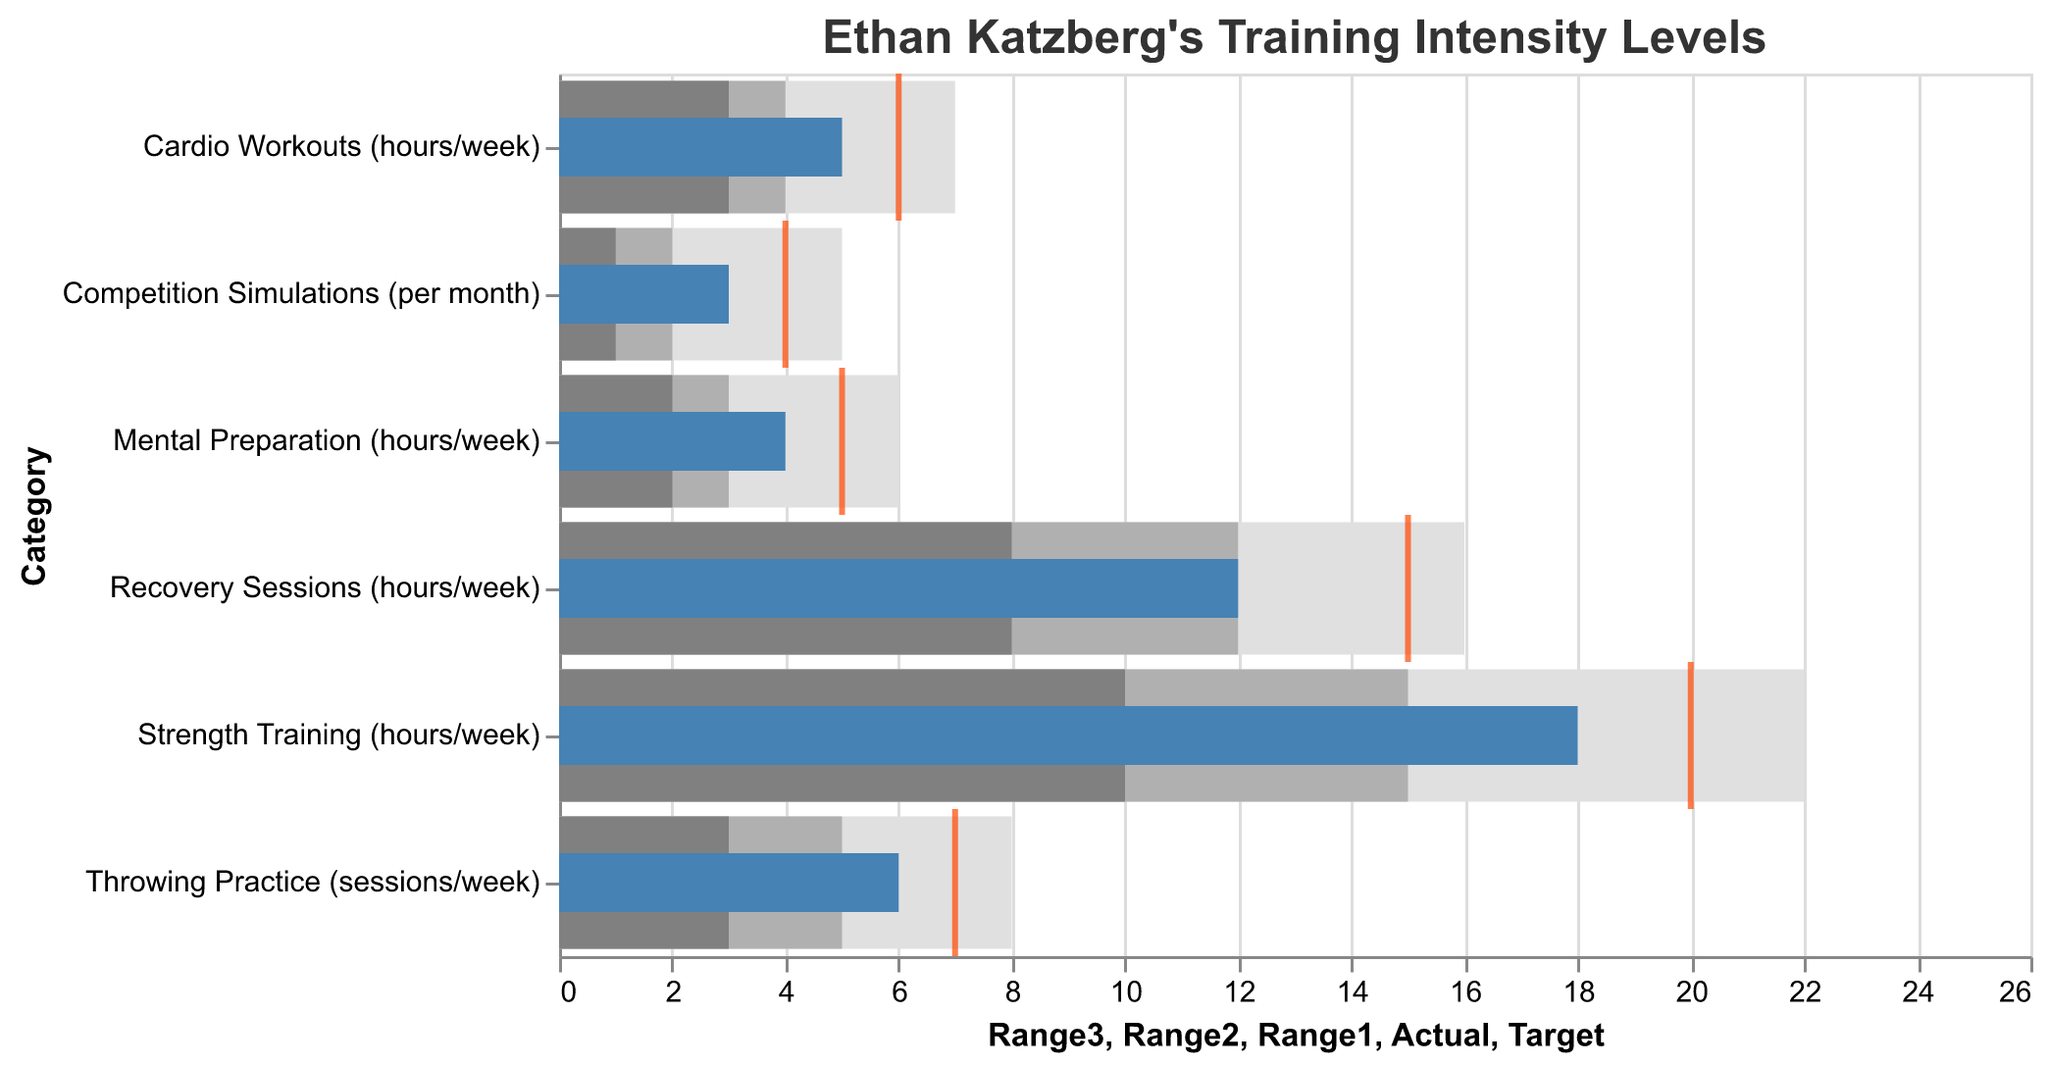What is the actual number of hours Ethan spends on Strength Training per week? The actual number of hours is represented by the blue bar associated with Strength Training.
Answer: 18 What are the optimal range limits for Recovery Sessions (hours/week)? The optimal range limits are shown by the different shades of bars: light gray, medium gray, and dark gray. For Recovery Sessions, these are 8 to 16 hours per week.
Answer: 8-16 Which training category has the closest actual value to its target? To find the closest actual to target value, compare the blue bars (actual) and red ticks (target) and identify the smallest gap. For Throwing Practice, the actual value (6) and target (7) have the smallest difference of 1.
Answer: Throwing Practice What is the target number of Competition Simulations per month? The target values are indicated by the red ticks on each category's bar. For Competition Simulations, the red tick is at 4.
Answer: 4 How many hours per week does Ethan actually spend on Mental Preparation compared to the optimal target? The actual value for Mental Preparation is shown by the blue bar and the target by the red tick. Ethan spends 4 hours per week, whereas the target is 5 hours.
Answer: 4 vs. 5 Which training category is furthest from its target, and by how much? Calculate the difference between the actual value (blue bar) and the target value (red tick) for all categories. The biggest difference is for Recovery Sessions, which is 15 (target) - 12 (actual) = 3 hours.
Answer: Recovery Sessions, 3 hours How does the actual number of Throwing Practice sessions per week compare to the upper bound of the optimal range? The upper bound of the optimal range for Throwing Practice is represented by the light gray bar at 8. Ethan's actual value is 6, which is below this upper bound.
Answer: 6 vs. 8 What is the range of Cardio Workouts (hours/week) in which Ethan's actual value falls? Ethan's actual value for Cardio Workouts is 5 hours/week. We need to see which shaded bar this falls into. This value falls within the medium gray range (4-7).
Answer: 4-7 